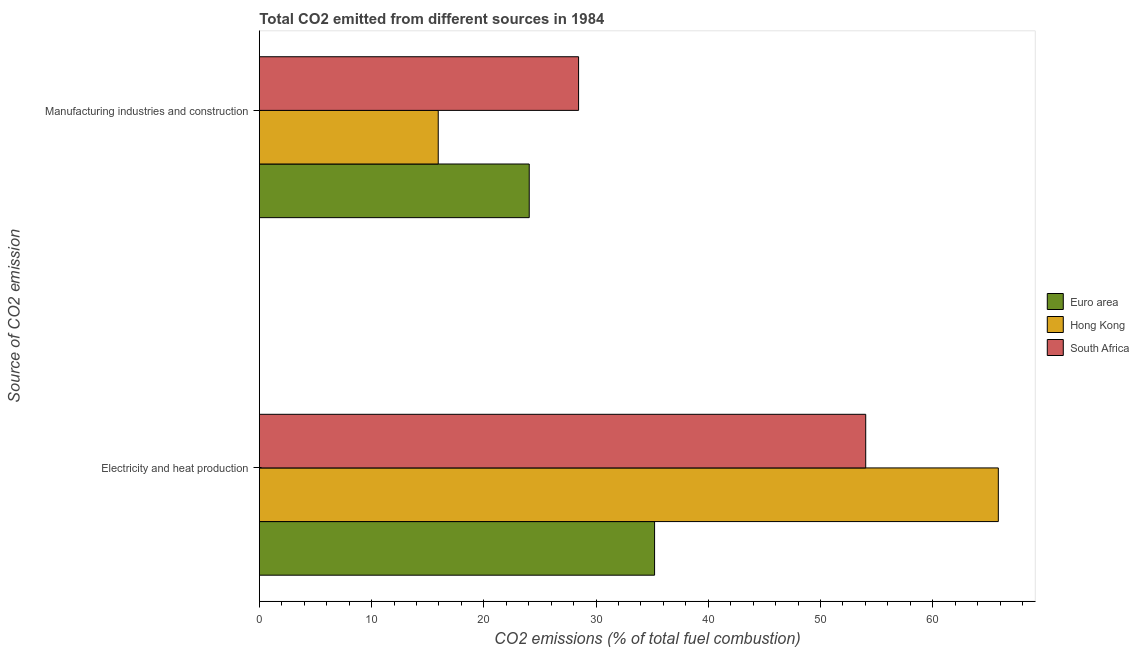Are the number of bars per tick equal to the number of legend labels?
Ensure brevity in your answer.  Yes. How many bars are there on the 1st tick from the top?
Your response must be concise. 3. How many bars are there on the 1st tick from the bottom?
Offer a very short reply. 3. What is the label of the 2nd group of bars from the top?
Provide a succinct answer. Electricity and heat production. What is the co2 emissions due to manufacturing industries in South Africa?
Offer a very short reply. 28.44. Across all countries, what is the maximum co2 emissions due to electricity and heat production?
Keep it short and to the point. 65.84. Across all countries, what is the minimum co2 emissions due to electricity and heat production?
Your response must be concise. 35.22. In which country was the co2 emissions due to manufacturing industries maximum?
Your response must be concise. South Africa. In which country was the co2 emissions due to manufacturing industries minimum?
Provide a succinct answer. Hong Kong. What is the total co2 emissions due to electricity and heat production in the graph?
Provide a succinct answer. 155.09. What is the difference between the co2 emissions due to electricity and heat production in Hong Kong and that in South Africa?
Ensure brevity in your answer.  11.82. What is the difference between the co2 emissions due to electricity and heat production in South Africa and the co2 emissions due to manufacturing industries in Hong Kong?
Provide a succinct answer. 38.09. What is the average co2 emissions due to manufacturing industries per country?
Provide a succinct answer. 22.81. What is the difference between the co2 emissions due to electricity and heat production and co2 emissions due to manufacturing industries in Euro area?
Offer a terse response. 11.17. What is the ratio of the co2 emissions due to electricity and heat production in Euro area to that in Hong Kong?
Provide a short and direct response. 0.53. Is the co2 emissions due to electricity and heat production in Hong Kong less than that in South Africa?
Give a very brief answer. No. In how many countries, is the co2 emissions due to electricity and heat production greater than the average co2 emissions due to electricity and heat production taken over all countries?
Keep it short and to the point. 2. What does the 2nd bar from the top in Manufacturing industries and construction represents?
Provide a short and direct response. Hong Kong. How many bars are there?
Your response must be concise. 6. Are all the bars in the graph horizontal?
Give a very brief answer. Yes. How many countries are there in the graph?
Keep it short and to the point. 3. What is the difference between two consecutive major ticks on the X-axis?
Keep it short and to the point. 10. Are the values on the major ticks of X-axis written in scientific E-notation?
Your answer should be compact. No. Does the graph contain grids?
Give a very brief answer. No. What is the title of the graph?
Make the answer very short. Total CO2 emitted from different sources in 1984. What is the label or title of the X-axis?
Your answer should be compact. CO2 emissions (% of total fuel combustion). What is the label or title of the Y-axis?
Offer a terse response. Source of CO2 emission. What is the CO2 emissions (% of total fuel combustion) in Euro area in Electricity and heat production?
Make the answer very short. 35.22. What is the CO2 emissions (% of total fuel combustion) in Hong Kong in Electricity and heat production?
Offer a terse response. 65.84. What is the CO2 emissions (% of total fuel combustion) of South Africa in Electricity and heat production?
Offer a very short reply. 54.03. What is the CO2 emissions (% of total fuel combustion) of Euro area in Manufacturing industries and construction?
Keep it short and to the point. 24.05. What is the CO2 emissions (% of total fuel combustion) of Hong Kong in Manufacturing industries and construction?
Provide a short and direct response. 15.94. What is the CO2 emissions (% of total fuel combustion) of South Africa in Manufacturing industries and construction?
Offer a very short reply. 28.44. Across all Source of CO2 emission, what is the maximum CO2 emissions (% of total fuel combustion) of Euro area?
Provide a short and direct response. 35.22. Across all Source of CO2 emission, what is the maximum CO2 emissions (% of total fuel combustion) in Hong Kong?
Offer a terse response. 65.84. Across all Source of CO2 emission, what is the maximum CO2 emissions (% of total fuel combustion) of South Africa?
Offer a very short reply. 54.03. Across all Source of CO2 emission, what is the minimum CO2 emissions (% of total fuel combustion) in Euro area?
Give a very brief answer. 24.05. Across all Source of CO2 emission, what is the minimum CO2 emissions (% of total fuel combustion) in Hong Kong?
Your response must be concise. 15.94. Across all Source of CO2 emission, what is the minimum CO2 emissions (% of total fuel combustion) in South Africa?
Keep it short and to the point. 28.44. What is the total CO2 emissions (% of total fuel combustion) of Euro area in the graph?
Provide a succinct answer. 59.26. What is the total CO2 emissions (% of total fuel combustion) in Hong Kong in the graph?
Your answer should be very brief. 81.78. What is the total CO2 emissions (% of total fuel combustion) of South Africa in the graph?
Provide a short and direct response. 82.47. What is the difference between the CO2 emissions (% of total fuel combustion) of Euro area in Electricity and heat production and that in Manufacturing industries and construction?
Make the answer very short. 11.17. What is the difference between the CO2 emissions (% of total fuel combustion) in Hong Kong in Electricity and heat production and that in Manufacturing industries and construction?
Provide a short and direct response. 49.91. What is the difference between the CO2 emissions (% of total fuel combustion) in South Africa in Electricity and heat production and that in Manufacturing industries and construction?
Give a very brief answer. 25.58. What is the difference between the CO2 emissions (% of total fuel combustion) in Euro area in Electricity and heat production and the CO2 emissions (% of total fuel combustion) in Hong Kong in Manufacturing industries and construction?
Offer a very short reply. 19.28. What is the difference between the CO2 emissions (% of total fuel combustion) of Euro area in Electricity and heat production and the CO2 emissions (% of total fuel combustion) of South Africa in Manufacturing industries and construction?
Provide a short and direct response. 6.77. What is the difference between the CO2 emissions (% of total fuel combustion) in Hong Kong in Electricity and heat production and the CO2 emissions (% of total fuel combustion) in South Africa in Manufacturing industries and construction?
Provide a succinct answer. 37.4. What is the average CO2 emissions (% of total fuel combustion) of Euro area per Source of CO2 emission?
Offer a terse response. 29.63. What is the average CO2 emissions (% of total fuel combustion) of Hong Kong per Source of CO2 emission?
Offer a very short reply. 40.89. What is the average CO2 emissions (% of total fuel combustion) of South Africa per Source of CO2 emission?
Make the answer very short. 41.24. What is the difference between the CO2 emissions (% of total fuel combustion) of Euro area and CO2 emissions (% of total fuel combustion) of Hong Kong in Electricity and heat production?
Offer a terse response. -30.63. What is the difference between the CO2 emissions (% of total fuel combustion) in Euro area and CO2 emissions (% of total fuel combustion) in South Africa in Electricity and heat production?
Your answer should be very brief. -18.81. What is the difference between the CO2 emissions (% of total fuel combustion) of Hong Kong and CO2 emissions (% of total fuel combustion) of South Africa in Electricity and heat production?
Give a very brief answer. 11.82. What is the difference between the CO2 emissions (% of total fuel combustion) in Euro area and CO2 emissions (% of total fuel combustion) in Hong Kong in Manufacturing industries and construction?
Give a very brief answer. 8.11. What is the difference between the CO2 emissions (% of total fuel combustion) in Euro area and CO2 emissions (% of total fuel combustion) in South Africa in Manufacturing industries and construction?
Provide a short and direct response. -4.4. What is the difference between the CO2 emissions (% of total fuel combustion) of Hong Kong and CO2 emissions (% of total fuel combustion) of South Africa in Manufacturing industries and construction?
Your answer should be compact. -12.51. What is the ratio of the CO2 emissions (% of total fuel combustion) in Euro area in Electricity and heat production to that in Manufacturing industries and construction?
Give a very brief answer. 1.46. What is the ratio of the CO2 emissions (% of total fuel combustion) in Hong Kong in Electricity and heat production to that in Manufacturing industries and construction?
Give a very brief answer. 4.13. What is the ratio of the CO2 emissions (% of total fuel combustion) of South Africa in Electricity and heat production to that in Manufacturing industries and construction?
Ensure brevity in your answer.  1.9. What is the difference between the highest and the second highest CO2 emissions (% of total fuel combustion) in Euro area?
Offer a very short reply. 11.17. What is the difference between the highest and the second highest CO2 emissions (% of total fuel combustion) of Hong Kong?
Make the answer very short. 49.91. What is the difference between the highest and the second highest CO2 emissions (% of total fuel combustion) of South Africa?
Your answer should be very brief. 25.58. What is the difference between the highest and the lowest CO2 emissions (% of total fuel combustion) of Euro area?
Keep it short and to the point. 11.17. What is the difference between the highest and the lowest CO2 emissions (% of total fuel combustion) of Hong Kong?
Give a very brief answer. 49.91. What is the difference between the highest and the lowest CO2 emissions (% of total fuel combustion) of South Africa?
Offer a terse response. 25.58. 